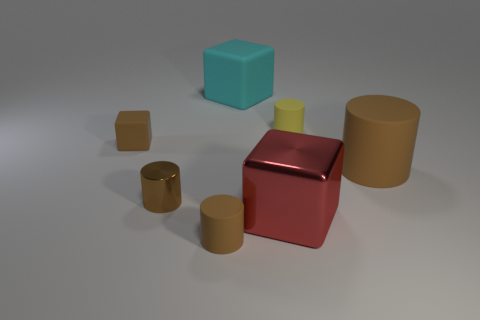How many brown cylinders must be subtracted to get 1 brown cylinders? 2 Subtract all large cylinders. How many cylinders are left? 3 Subtract all brown cubes. How many cubes are left? 2 Add 2 large rubber cubes. How many objects exist? 9 Subtract all brown balls. How many brown cylinders are left? 3 Subtract all cylinders. How many objects are left? 3 Subtract 2 cylinders. How many cylinders are left? 2 Subtract all big blue rubber things. Subtract all tiny yellow cylinders. How many objects are left? 6 Add 1 small matte blocks. How many small matte blocks are left? 2 Add 3 tiny yellow rubber cylinders. How many tiny yellow rubber cylinders exist? 4 